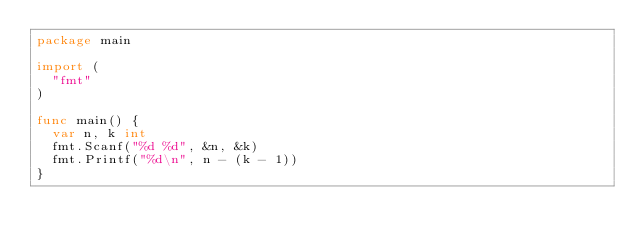Convert code to text. <code><loc_0><loc_0><loc_500><loc_500><_Go_>package main
 
import (
	"fmt"
)
 
func main() {
	var n, k int
	fmt.Scanf("%d %d", &n, &k)
	fmt.Printf("%d\n", n - (k - 1))
}</code> 